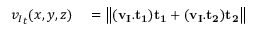<formula> <loc_0><loc_0><loc_500><loc_500>\begin{array} { r l } { { v _ { I } } _ { t } ( x , y , z ) } & = \left \| ( v _ { I } . { t _ { 1 } } ) { t _ { 1 } } + ( v _ { I } . { t _ { 2 } } ) { t _ { 2 } } \right \| } \end{array}</formula> 